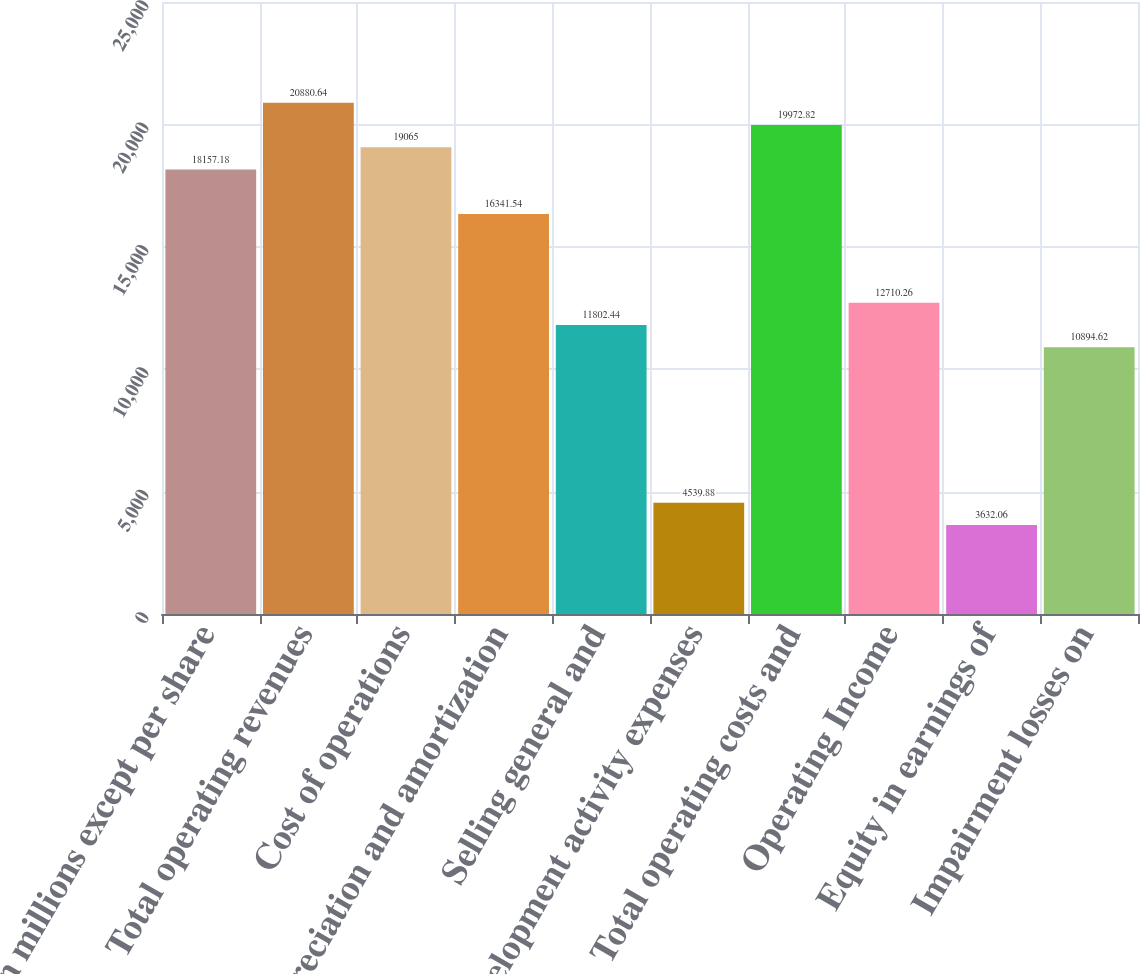Convert chart to OTSL. <chart><loc_0><loc_0><loc_500><loc_500><bar_chart><fcel>(In millions except per share<fcel>Total operating revenues<fcel>Cost of operations<fcel>Depreciation and amortization<fcel>Selling general and<fcel>Development activity expenses<fcel>Total operating costs and<fcel>Operating Income<fcel>Equity in earnings of<fcel>Impairment losses on<nl><fcel>18157.2<fcel>20880.6<fcel>19065<fcel>16341.5<fcel>11802.4<fcel>4539.88<fcel>19972.8<fcel>12710.3<fcel>3632.06<fcel>10894.6<nl></chart> 